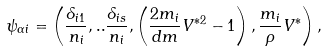<formula> <loc_0><loc_0><loc_500><loc_500>\psi _ { \alpha i } = \left ( \frac { \delta _ { i 1 } } { n _ { i } } , . . \frac { \delta _ { i s } } { n _ { i } } , \left ( \frac { 2 m _ { i } } { d m } V ^ { \ast 2 } - 1 \right ) , \frac { m _ { i } } { \rho } V ^ { \ast } \right ) ,</formula> 